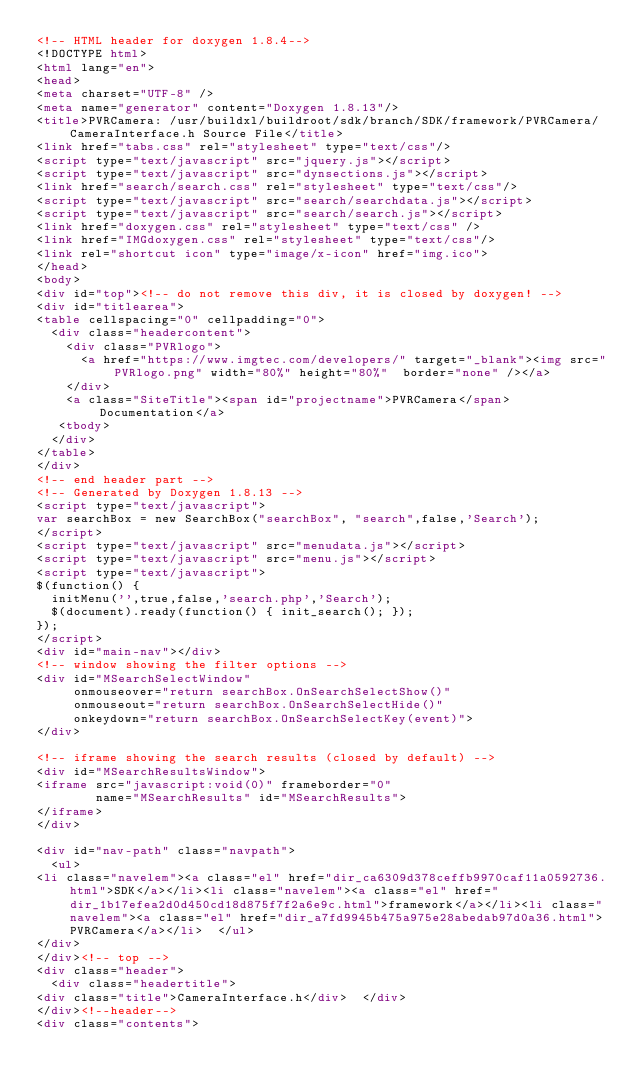Convert code to text. <code><loc_0><loc_0><loc_500><loc_500><_HTML_><!-- HTML header for doxygen 1.8.4-->
<!DOCTYPE html>
<html lang="en">
<head>
<meta charset="UTF-8" />
<meta name="generator" content="Doxygen 1.8.13"/>
<title>PVRCamera: /usr/buildxl/buildroot/sdk/branch/SDK/framework/PVRCamera/CameraInterface.h Source File</title>
<link href="tabs.css" rel="stylesheet" type="text/css"/>
<script type="text/javascript" src="jquery.js"></script>
<script type="text/javascript" src="dynsections.js"></script>
<link href="search/search.css" rel="stylesheet" type="text/css"/>
<script type="text/javascript" src="search/searchdata.js"></script>
<script type="text/javascript" src="search/search.js"></script>
<link href="doxygen.css" rel="stylesheet" type="text/css" />
<link href="IMGdoxygen.css" rel="stylesheet" type="text/css"/>
<link rel="shortcut icon" type="image/x-icon" href="img.ico">
</head>
<body>
<div id="top"><!-- do not remove this div, it is closed by doxygen! -->
<div id="titlearea">
<table cellspacing="0" cellpadding="0">
  <div class="headercontent">
    <div class="PVRlogo">
      <a href="https://www.imgtec.com/developers/" target="_blank"><img src="PVRlogo.png" width="80%" height="80%"  border="none" /></a>
    </div>
    <a class="SiteTitle"><span id="projectname">PVRCamera</span> Documentation</a>
   <tbody>
  </div>
</table>
</div>
<!-- end header part -->
<!-- Generated by Doxygen 1.8.13 -->
<script type="text/javascript">
var searchBox = new SearchBox("searchBox", "search",false,'Search');
</script>
<script type="text/javascript" src="menudata.js"></script>
<script type="text/javascript" src="menu.js"></script>
<script type="text/javascript">
$(function() {
  initMenu('',true,false,'search.php','Search');
  $(document).ready(function() { init_search(); });
});
</script>
<div id="main-nav"></div>
<!-- window showing the filter options -->
<div id="MSearchSelectWindow"
     onmouseover="return searchBox.OnSearchSelectShow()"
     onmouseout="return searchBox.OnSearchSelectHide()"
     onkeydown="return searchBox.OnSearchSelectKey(event)">
</div>

<!-- iframe showing the search results (closed by default) -->
<div id="MSearchResultsWindow">
<iframe src="javascript:void(0)" frameborder="0" 
        name="MSearchResults" id="MSearchResults">
</iframe>
</div>

<div id="nav-path" class="navpath">
  <ul>
<li class="navelem"><a class="el" href="dir_ca6309d378ceffb9970caf11a0592736.html">SDK</a></li><li class="navelem"><a class="el" href="dir_1b17efea2d0d450cd18d875f7f2a6e9c.html">framework</a></li><li class="navelem"><a class="el" href="dir_a7fd9945b475a975e28abedab97d0a36.html">PVRCamera</a></li>  </ul>
</div>
</div><!-- top -->
<div class="header">
  <div class="headertitle">
<div class="title">CameraInterface.h</div>  </div>
</div><!--header-->
<div class="contents"></code> 